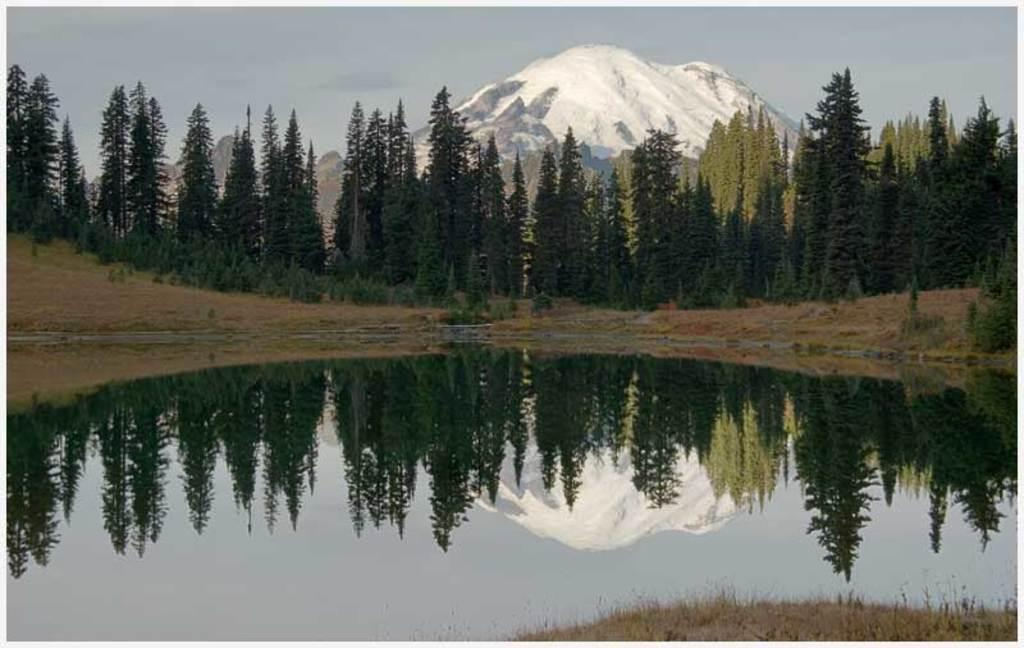What is the primary element visible in the picture? There is water in the picture. What can be seen in the background of the picture? There are trees and mountains in the background of the picture. Where is the store located in the picture? There is no store present in the picture; it features water, trees, and mountains. 